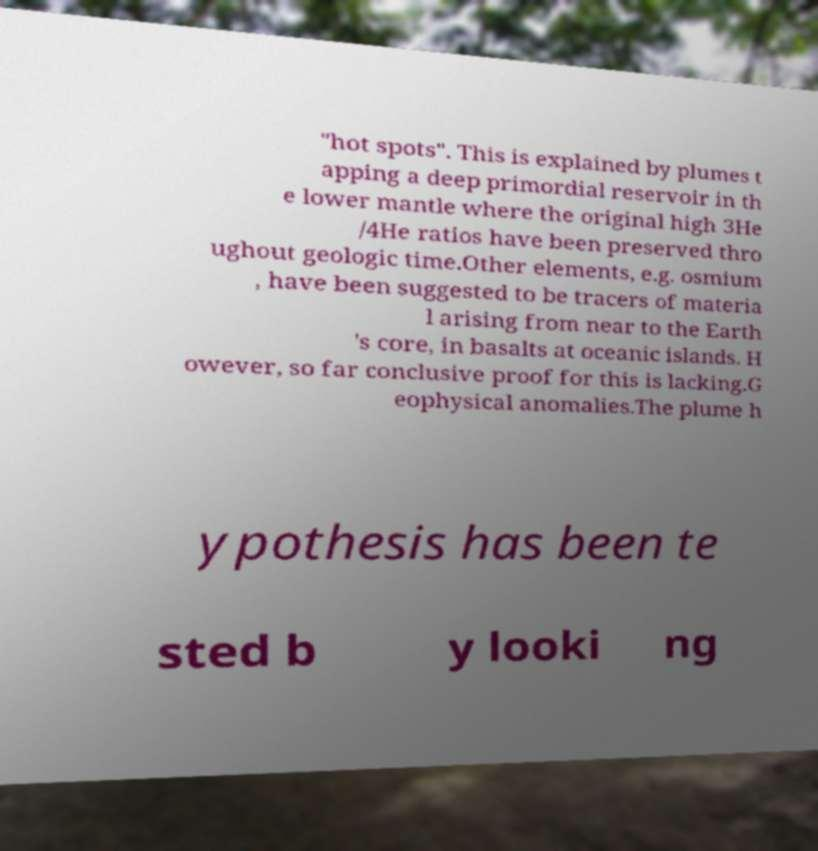Can you accurately transcribe the text from the provided image for me? "hot spots". This is explained by plumes t apping a deep primordial reservoir in th e lower mantle where the original high 3He /4He ratios have been preserved thro ughout geologic time.Other elements, e.g. osmium , have been suggested to be tracers of materia l arising from near to the Earth 's core, in basalts at oceanic islands. H owever, so far conclusive proof for this is lacking.G eophysical anomalies.The plume h ypothesis has been te sted b y looki ng 